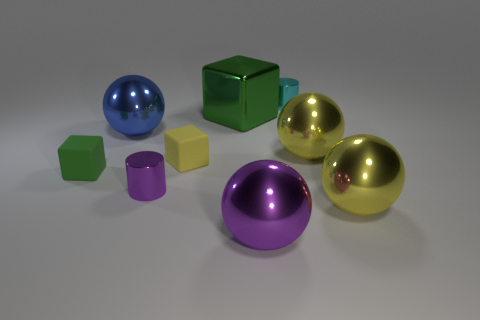Subtract all green blocks. How many were subtracted if there are1green blocks left? 1 Subtract all matte cubes. How many cubes are left? 1 Subtract all purple cylinders. How many cylinders are left? 1 Subtract all brown balls. How many green cubes are left? 2 Subtract 3 balls. How many balls are left? 1 Add 1 big purple metallic objects. How many objects exist? 10 Subtract all blocks. How many objects are left? 6 Subtract all red blocks. Subtract all brown spheres. How many blocks are left? 3 Subtract all small purple cylinders. Subtract all small cyan metal objects. How many objects are left? 7 Add 8 purple shiny cylinders. How many purple shiny cylinders are left? 9 